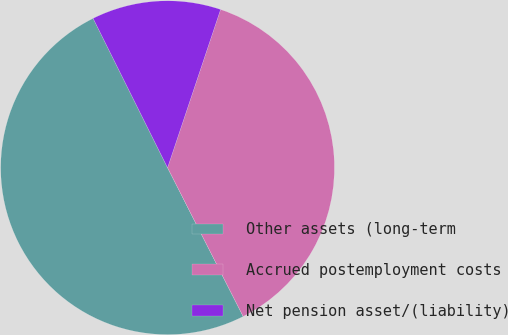Convert chart. <chart><loc_0><loc_0><loc_500><loc_500><pie_chart><fcel>Other assets (long-term<fcel>Accrued postemployment costs<fcel>Net pension asset/(liability)<nl><fcel>50.12%<fcel>37.37%<fcel>12.51%<nl></chart> 